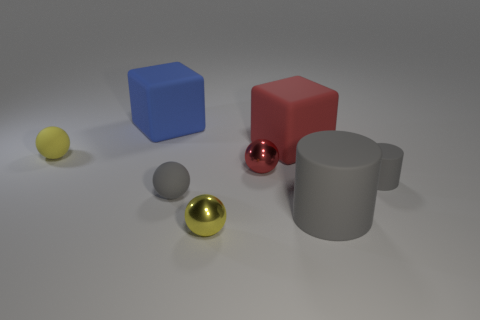Add 1 red rubber objects. How many objects exist? 9 Subtract all cylinders. How many objects are left? 6 Subtract all big shiny spheres. Subtract all gray things. How many objects are left? 5 Add 3 rubber cylinders. How many rubber cylinders are left? 5 Add 4 red rubber things. How many red rubber things exist? 5 Subtract 1 red cubes. How many objects are left? 7 